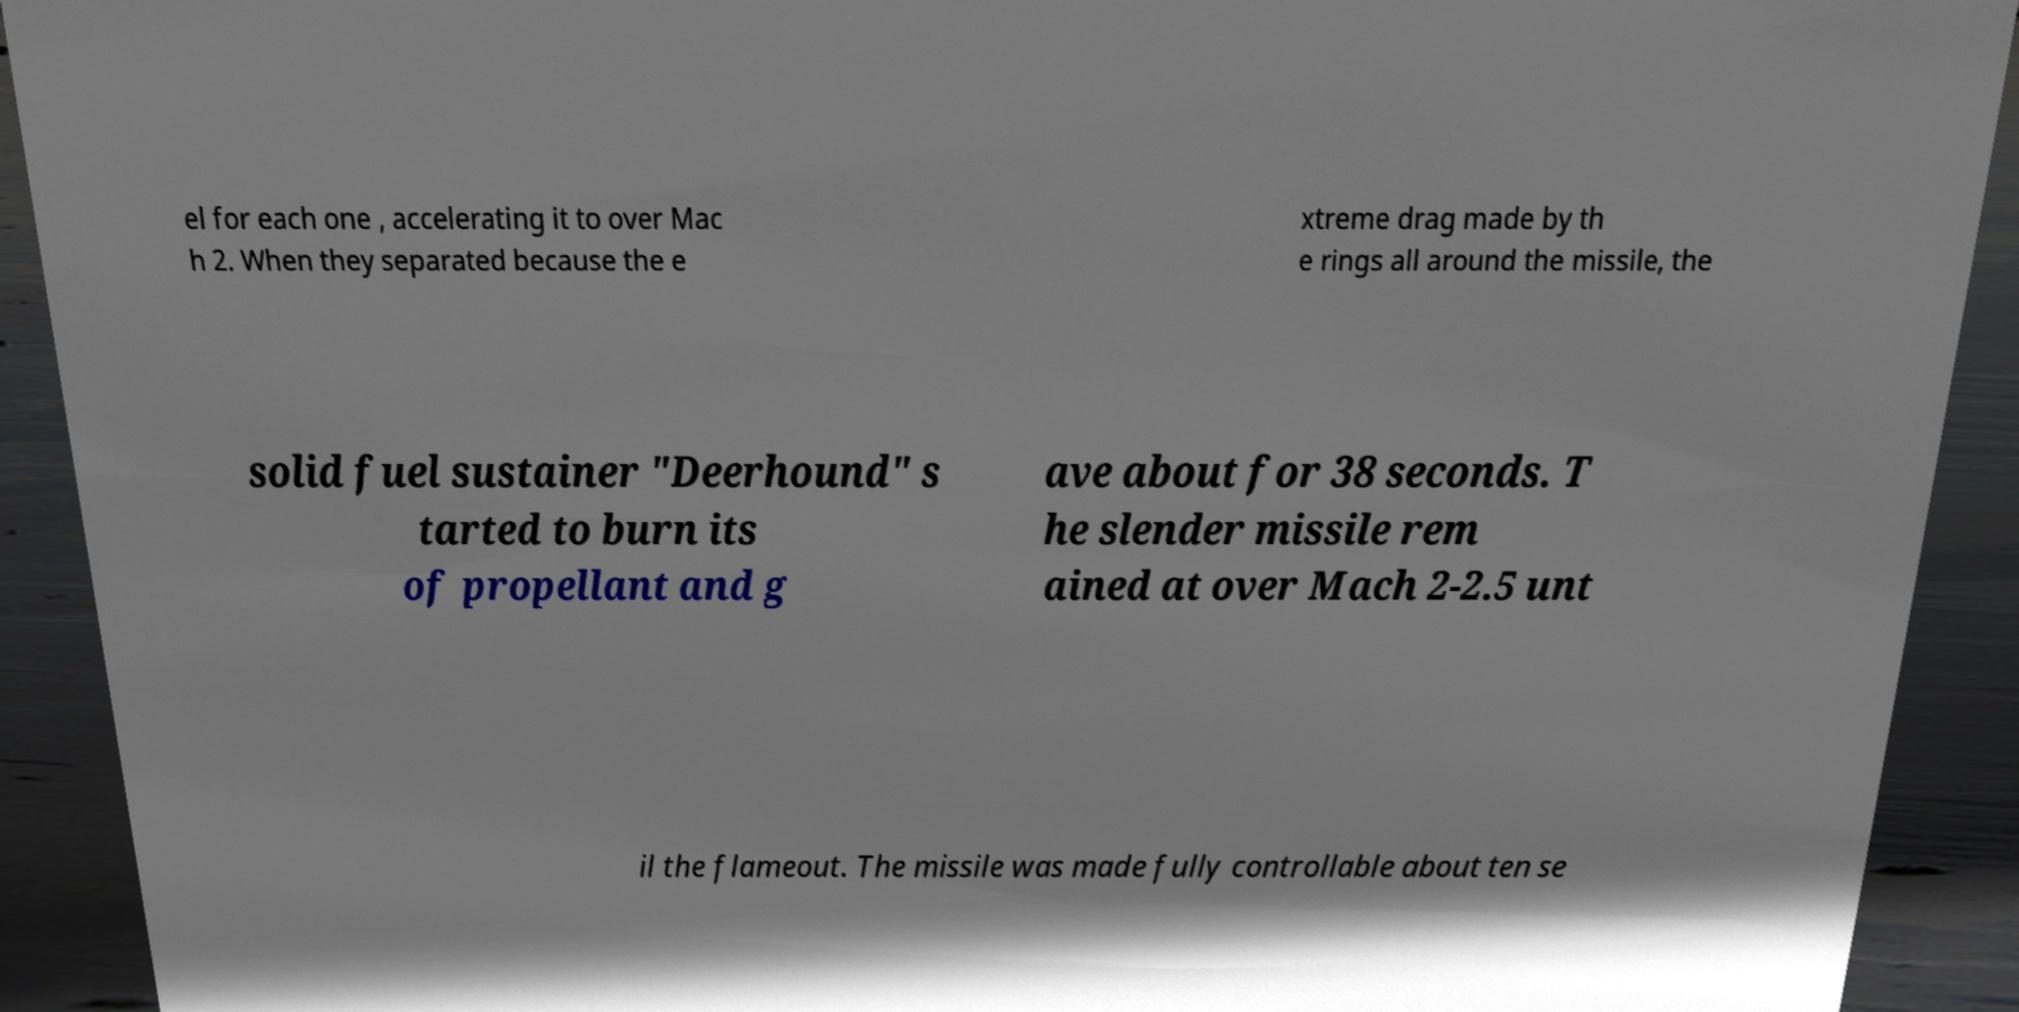Could you assist in decoding the text presented in this image and type it out clearly? el for each one , accelerating it to over Mac h 2. When they separated because the e xtreme drag made by th e rings all around the missile, the solid fuel sustainer "Deerhound" s tarted to burn its of propellant and g ave about for 38 seconds. T he slender missile rem ained at over Mach 2-2.5 unt il the flameout. The missile was made fully controllable about ten se 